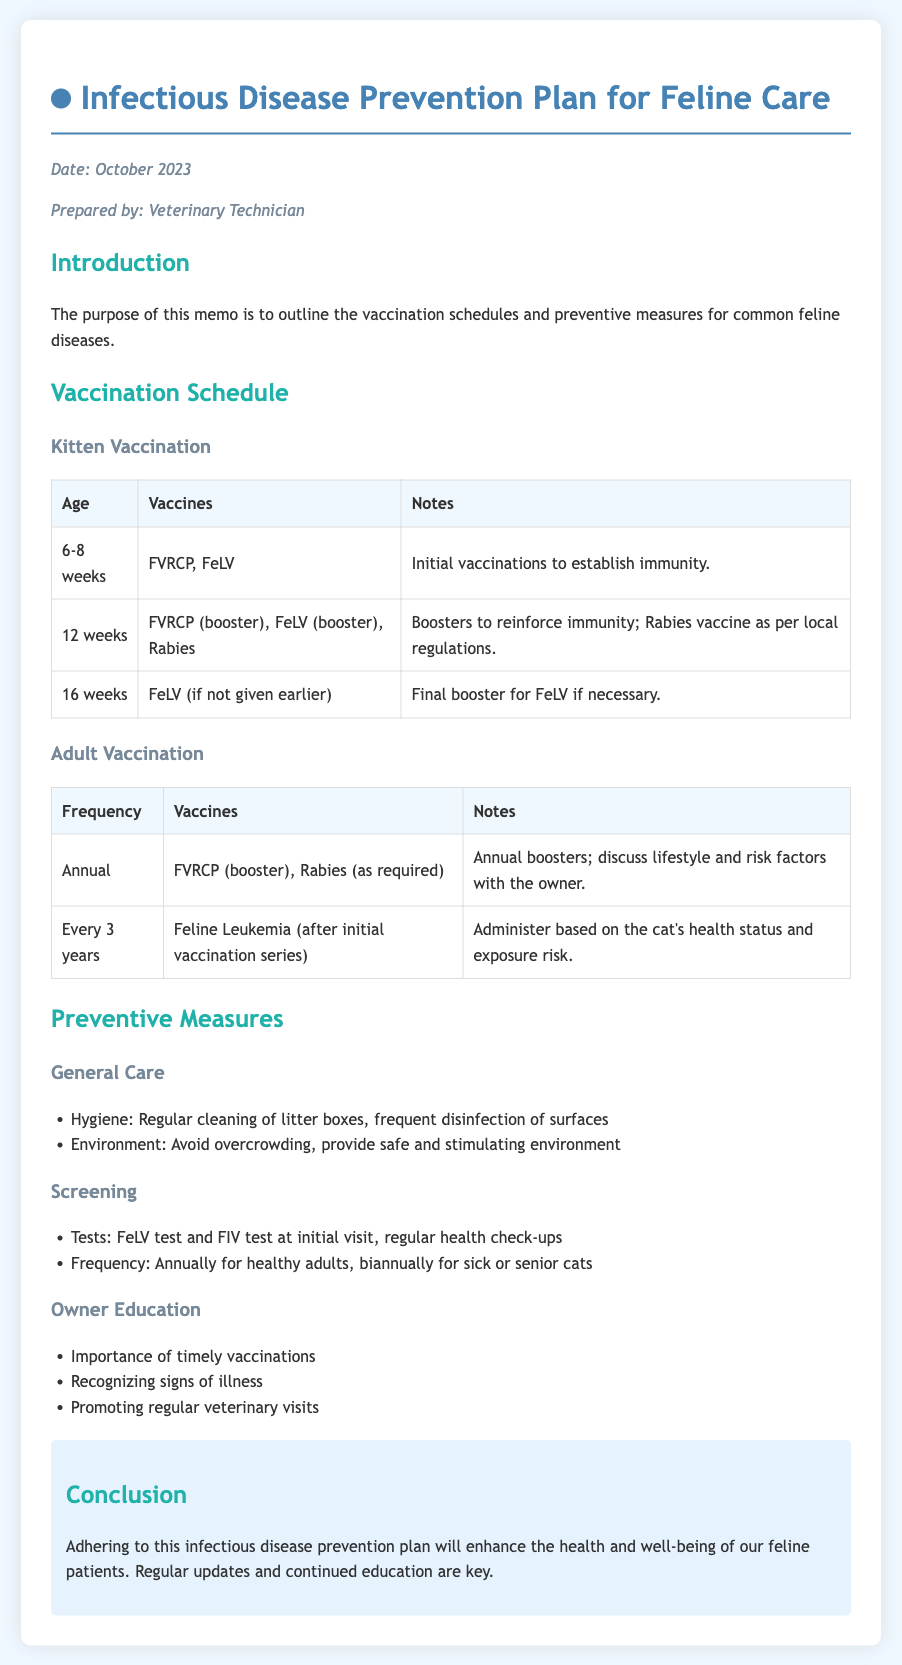what is the purpose of the memo? The purpose of the memo is stated in the introduction section, which explains the outline of vaccination schedules and preventive measures for common feline diseases.
Answer: outline vaccination schedules and preventive measures what vaccine is given at 6-8 weeks? The table for Kitten Vaccination specifies the vaccines given at this age, which includes FVRCP and FeLV.
Answer: FVRCP, FeLV how often should adult cats receive the FVRCP booster? The adult vaccination schedule indicates that the FVRCP booster should be given annually.
Answer: Annual what is the FeLV test frequency for healthy adult cats? The Screening section mentions that the FeLV test should be done annually for healthy adults.
Answer: Annually what preventive measure involves hygiene? The General Care section lists hygiene practices that include regular cleaning of litter boxes and frequent disinfection of surfaces.
Answer: Regular cleaning of litter boxes how often should sick or senior cats have health check-ups? According to the Screening section, sick or senior cats require health check-ups biannually.
Answer: Biannually what is a key factor in owner education? The Owner Education section highlights the importance of timely vaccinations as a key factor.
Answer: Timely vaccinations what is the conclusion of the memo? The conclusion summarizes that adhering to the prevention plan will enhance the health and well-being of feline patients.
Answer: Enhance the health and well-being of feline patients 